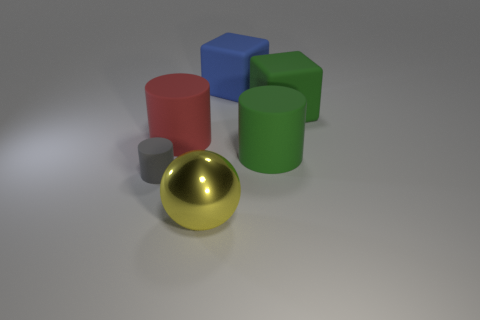Is there any other thing that has the same material as the large yellow thing?
Your answer should be compact. No. The metallic ball is what color?
Your response must be concise. Yellow. What is the shape of the large object behind the large green object behind the cylinder that is to the right of the large ball?
Offer a very short reply. Cube. How many other things are the same color as the metal ball?
Give a very brief answer. 0. Is the number of rubber cubes that are to the left of the big blue rubber thing greater than the number of big blue things that are on the left side of the tiny rubber object?
Offer a very short reply. No. There is a tiny gray cylinder; are there any matte cubes in front of it?
Your answer should be compact. No. The thing that is both to the left of the blue matte cube and behind the tiny matte cylinder is made of what material?
Provide a succinct answer. Rubber. What color is the other big thing that is the same shape as the blue thing?
Offer a very short reply. Green. Are there any tiny cylinders in front of the large green thing that is behind the large red thing?
Provide a short and direct response. Yes. How big is the blue matte block?
Give a very brief answer. Large. 